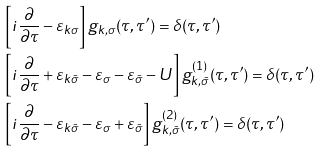<formula> <loc_0><loc_0><loc_500><loc_500>& \left [ i \frac { \partial } { \partial \tau } - \varepsilon _ { k \sigma } \right ] g _ { k , \sigma } ( \tau , \tau ^ { \prime } ) = \delta ( \tau , \tau ^ { \prime } ) \\ & \left [ i \frac { \partial } { \partial \tau } + \varepsilon _ { k \bar { \sigma } } - \varepsilon _ { \sigma } - \varepsilon _ { \bar { \sigma } } - U \right ] g _ { k , \bar { \sigma } } ^ { ( 1 ) } ( \tau , \tau ^ { \prime } ) = \delta ( \tau , \tau ^ { \prime } ) \\ & \left [ i \frac { \partial } { \partial \tau } - \varepsilon _ { k \bar { \sigma } } - \varepsilon _ { \sigma } + \varepsilon _ { \bar { \sigma } } \right ] g _ { k , \bar { \sigma } } ^ { ( 2 ) } ( \tau , \tau ^ { \prime } ) = \delta ( \tau , \tau ^ { \prime } )</formula> 